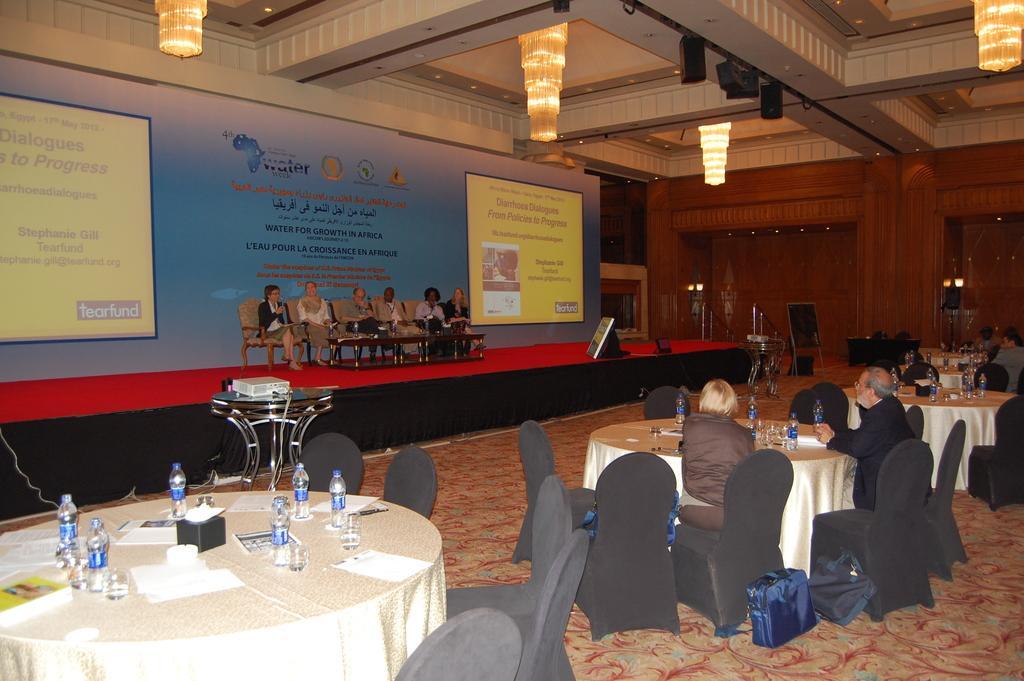In one or two sentences, can you explain what this image depicts? In the image we can see there are people who are sitting on chair and on table there are water bottles. 